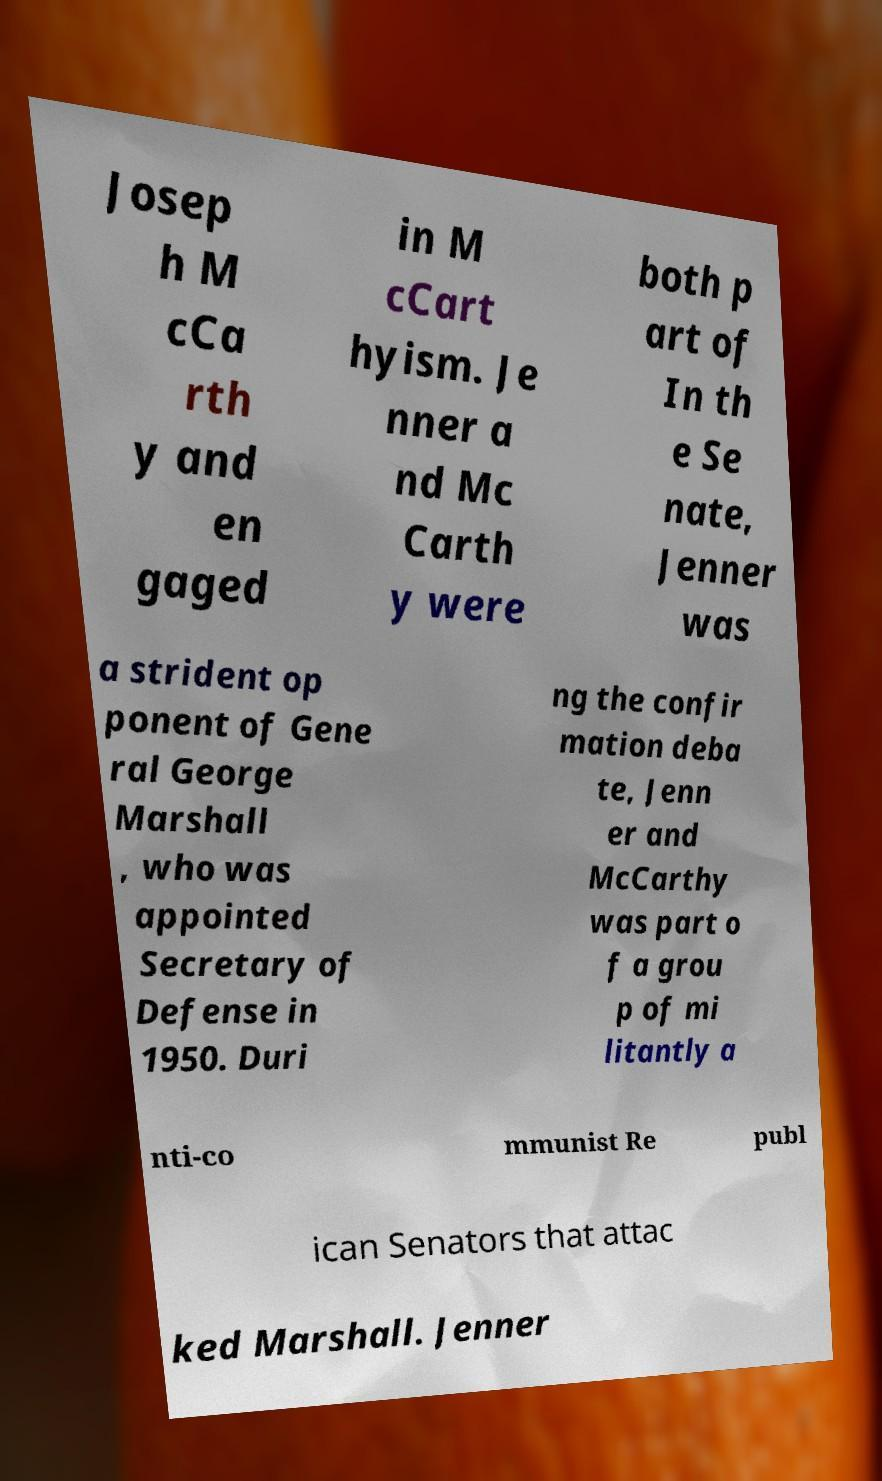Can you accurately transcribe the text from the provided image for me? Josep h M cCa rth y and en gaged in M cCart hyism. Je nner a nd Mc Carth y were both p art of In th e Se nate, Jenner was a strident op ponent of Gene ral George Marshall , who was appointed Secretary of Defense in 1950. Duri ng the confir mation deba te, Jenn er and McCarthy was part o f a grou p of mi litantly a nti-co mmunist Re publ ican Senators that attac ked Marshall. Jenner 